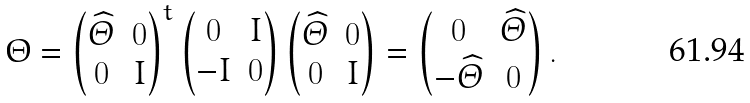Convert formula to latex. <formula><loc_0><loc_0><loc_500><loc_500>\Theta = \begin{pmatrix} \widehat { \varTheta } & 0 \\ 0 & I \end{pmatrix} ^ { t } \begin{pmatrix} 0 & I \\ - I & 0 \end{pmatrix} \begin{pmatrix} \widehat { \varTheta } & 0 \\ 0 & I \end{pmatrix} = \begin{pmatrix} 0 & \widehat { \varTheta } \\ - \widehat { \varTheta } & 0 \end{pmatrix} .</formula> 